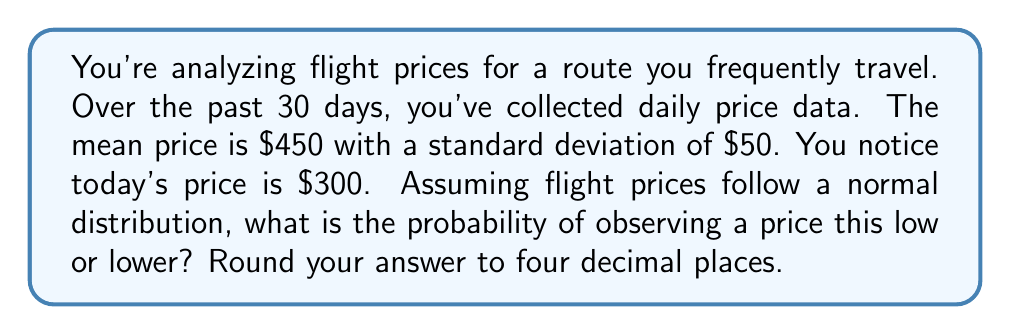Teach me how to tackle this problem. To solve this problem, we'll use the concept of z-scores and the standard normal distribution.

1) First, calculate the z-score for the observed price:

   $z = \frac{x - \mu}{\sigma}$

   Where:
   $x$ = observed price = $300
   $\mu$ = mean price = $450
   $\sigma$ = standard deviation = $50

   $z = \frac{300 - 450}{50} = -3$

2) This z-score tells us that the observed price is 3 standard deviations below the mean.

3) To find the probability of observing a price this low or lower, we need to find the area under the standard normal curve to the left of z = -3.

4) Using a standard normal distribution table or calculator, we can find:

   $P(Z \leq -3) \approx 0.00135$

5) This probability represents the chance of observing a price of $300 or lower, given the normal distribution of prices with mean $450 and standard deviation $50.

6) Rounding to four decimal places: 0.0014

This extremely low probability suggests that this price is indeed an anomaly and could represent a potential deal or pricing error.
Answer: 0.0014 